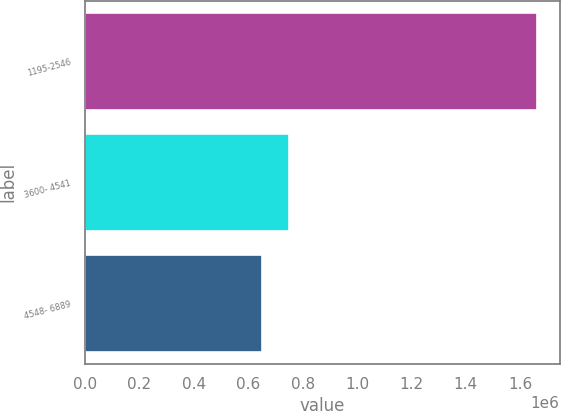<chart> <loc_0><loc_0><loc_500><loc_500><bar_chart><fcel>1195-2546<fcel>3600- 4541<fcel>4548- 6889<nl><fcel>1.66259e+06<fcel>751768<fcel>650565<nl></chart> 